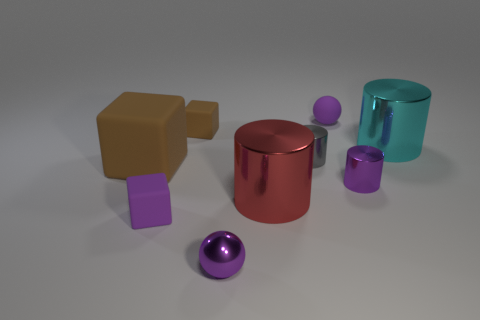Subtract all cylinders. How many objects are left? 5 Subtract 1 purple cylinders. How many objects are left? 8 Subtract all gray metallic objects. Subtract all cylinders. How many objects are left? 4 Add 7 brown matte things. How many brown matte things are left? 9 Add 4 big matte cubes. How many big matte cubes exist? 5 